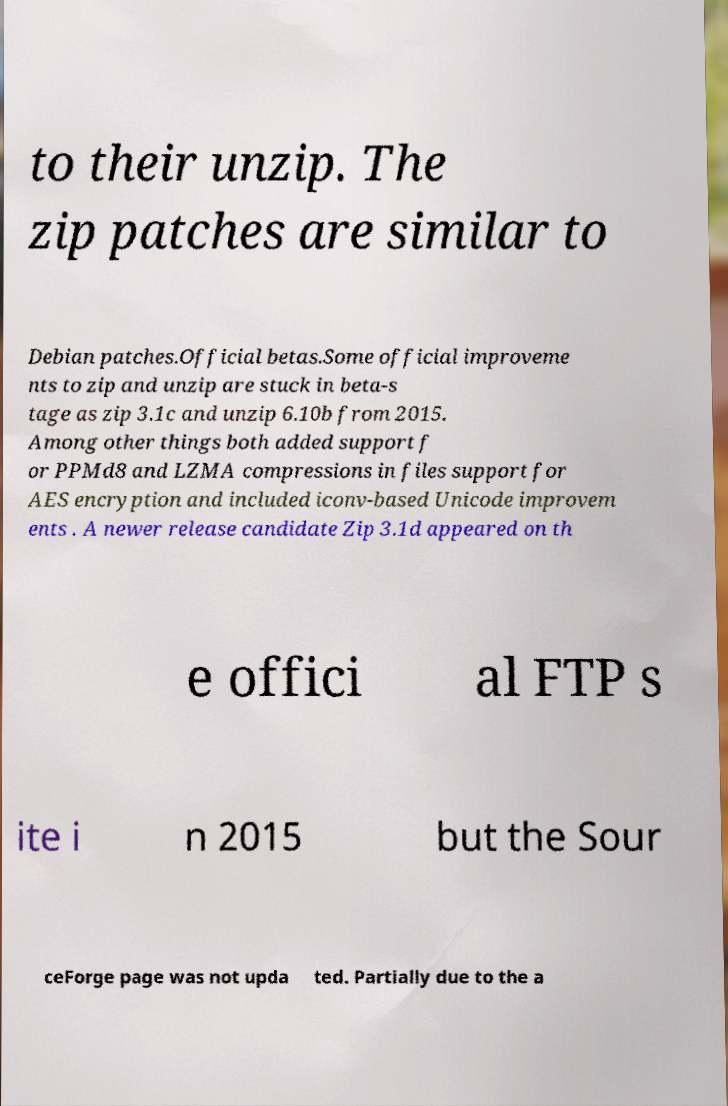I need the written content from this picture converted into text. Can you do that? to their unzip. The zip patches are similar to Debian patches.Official betas.Some official improveme nts to zip and unzip are stuck in beta-s tage as zip 3.1c and unzip 6.10b from 2015. Among other things both added support f or PPMd8 and LZMA compressions in files support for AES encryption and included iconv-based Unicode improvem ents . A newer release candidate Zip 3.1d appeared on th e offici al FTP s ite i n 2015 but the Sour ceForge page was not upda ted. Partially due to the a 